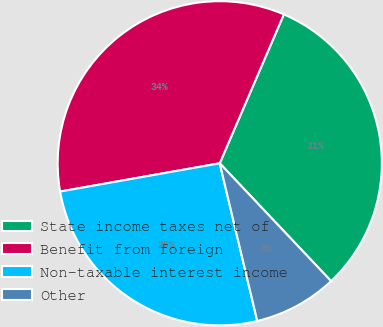<chart> <loc_0><loc_0><loc_500><loc_500><pie_chart><fcel>State income taxes net of<fcel>Benefit from foreign<fcel>Non-taxable interest income<fcel>Other<nl><fcel>31.48%<fcel>34.26%<fcel>25.93%<fcel>8.33%<nl></chart> 